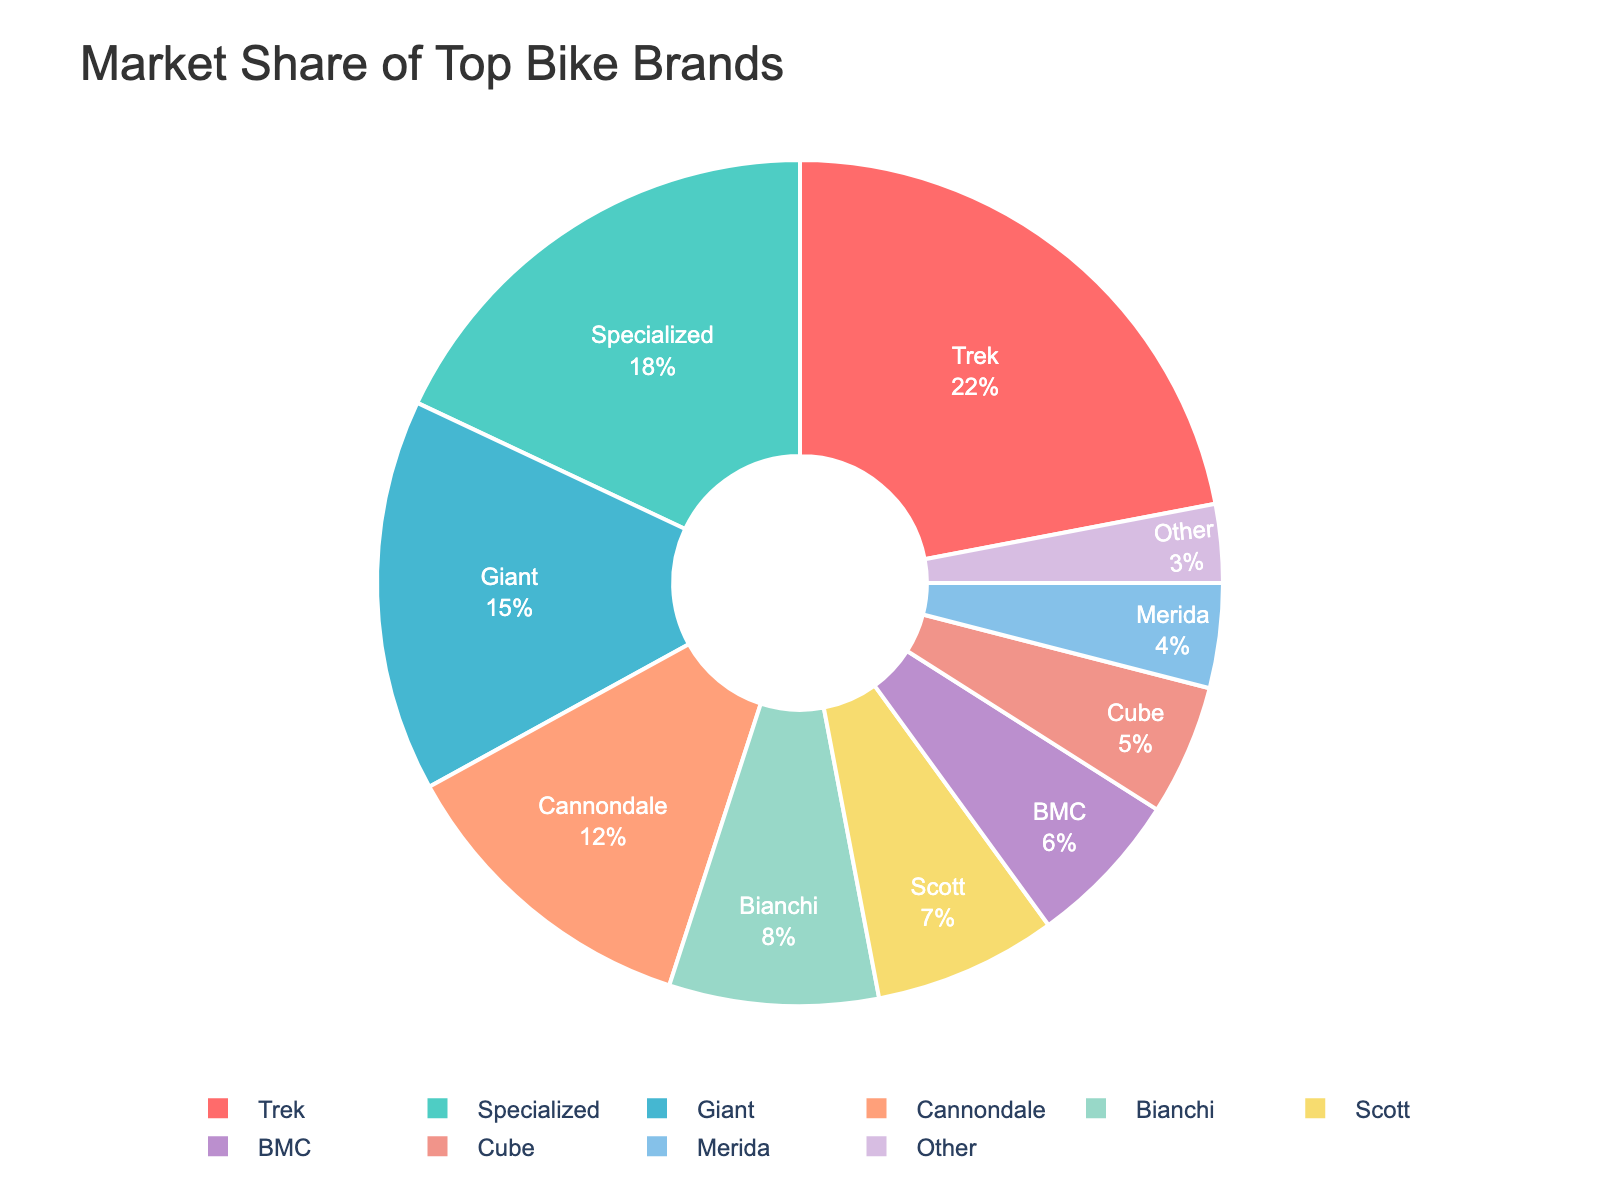Which bike brand has the highest market share? From the pie chart, the segment with the largest proportion represents the brand with the highest market share. In this case, Trek has the largest segment.
Answer: Trek Which bike brand has the lowest market share? The smallest segment in the pie chart represents the brand with the lowest market share. In this case, the "Other" category has the smallest segment.
Answer: Other What is the combined market share of Cannondale and Specialized? From the pie chart, Cannondale has a 12% market share and Specialized has an 18% market share. Combined, their market share is 12% + 18% = 30%.
Answer: 30% Which brand has a greater market share, Bianchi or Scott? By comparing the segments, Bianchi has an 8% market share while Scott has a 7% market share. Thus, Bianchi has a greater market share.
Answer: Bianchi What is the total market share of brands that have less than 10% market share each? Adding up the market shares of brands with less than 10% each: Bianchi (8%) + Scott (7%) + BMC (6%) + Cube (5%) + Merida (4%) + Other (3%) = 33%.
Answer: 33% How does the market share of Giant compare to that of Cannondale? From the pie chart, Giant has a 15% market share and Cannondale has a 12% market share. Therefore, Giant's market share is higher.
Answer: Giant What is the difference in market share between the brands with the largest and smallest market shares? Trek has the largest market share with 22%, and Other has the smallest market share with 3%. The difference is 22% - 3% = 19%.
Answer: 19% Which brands have a market share within 2% of each other, and what are those market shares? Scott has a 7% market share and BMC has a 6% market share, which are within 2% of each other.
Answer: Scott and BMC, 7% and 6% What is the average market share of the brands other than Trek and Specialized? Excluding Trek (22%) and Specialized (18%), the remaining market shares are 15%, 12%, 8%, 7%, 6%, 5%, 4%, and 3%. Adding these and dividing by the number of brands: (15 + 12 + 8 + 7 + 6 + 5 + 4 + 3) / 8 = 7.5%.
Answer: 7.5% 